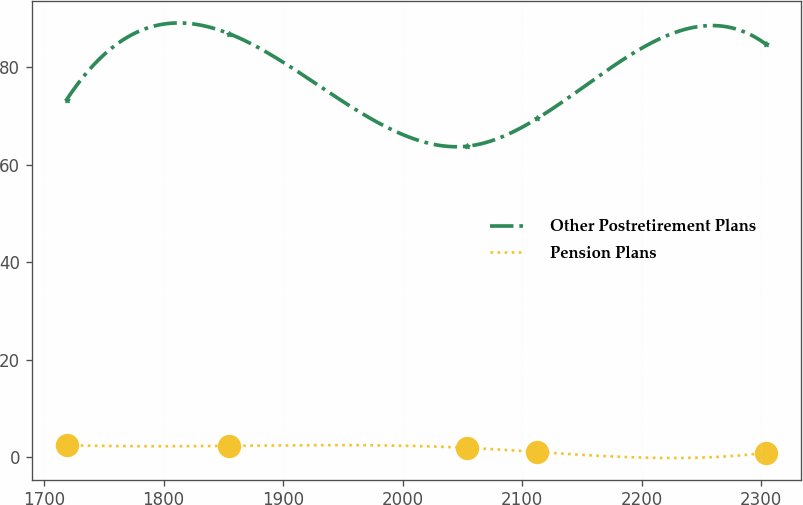Convert chart. <chart><loc_0><loc_0><loc_500><loc_500><line_chart><ecel><fcel>Other Postretirement Plans<fcel>Pension Plans<nl><fcel>1718.79<fcel>73.35<fcel>2.45<nl><fcel>1854.52<fcel>86.95<fcel>2.3<nl><fcel>2053.99<fcel>63.82<fcel>1.9<nl><fcel>2112.52<fcel>69.51<fcel>1.04<nl><fcel>2304.1<fcel>84.73<fcel>0.89<nl></chart> 